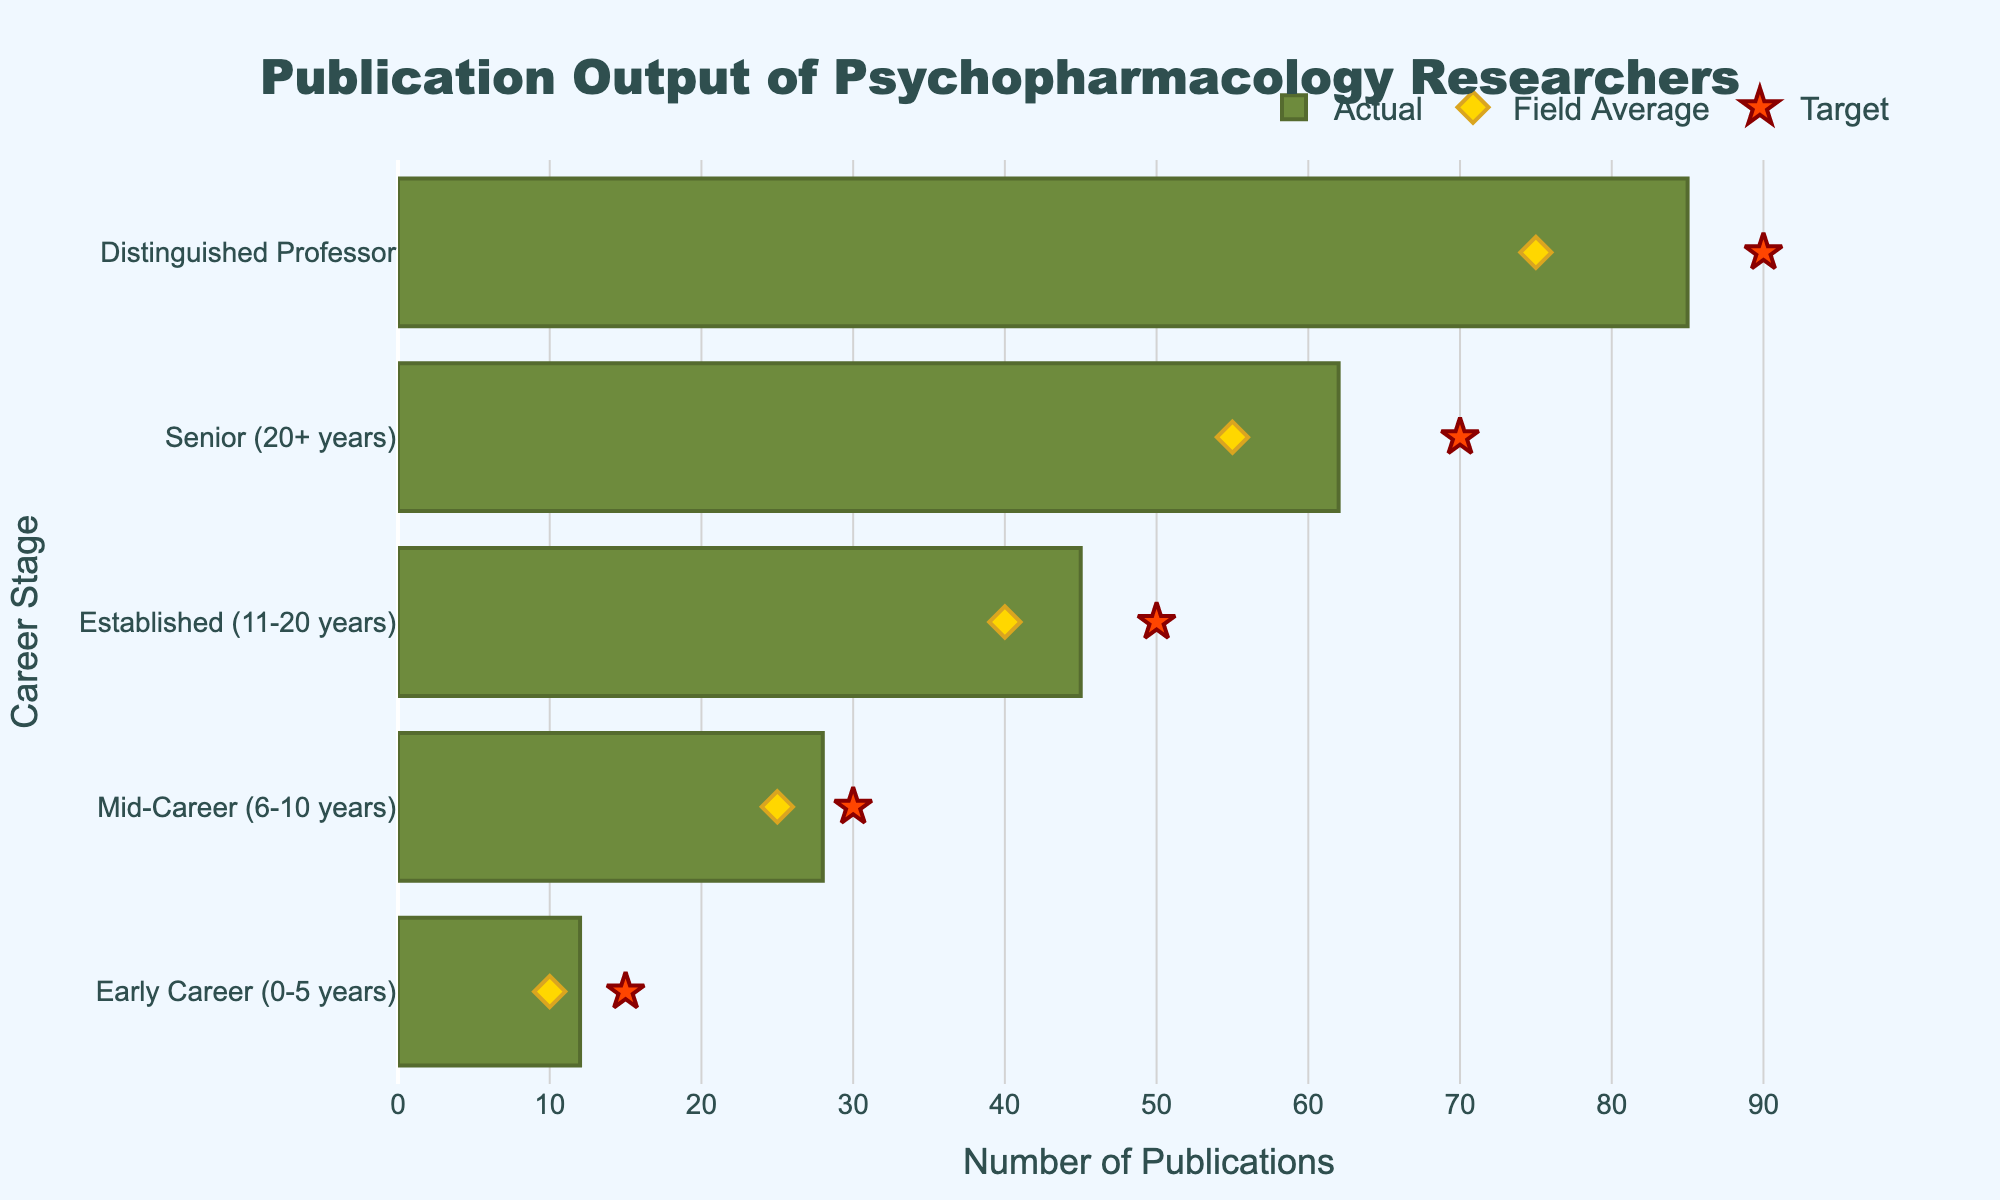How many career stages are illustrated in the chart? There are different career stages listed on the y-axis of the chart. Counting them will give us the total number of career stages.
Answer: Five What is the title of the chart? The title is displayed prominently at the top center of the chart.
Answer: Publication Output of Psychopharmacology Researchers What is the actual publication output for Mid-Career researchers? Look for the Mid-Career category on the y-axis and identify the length of the corresponding bar.
Answer: 28 What is the difference between the actual publication output and the target for Early Career researchers? For Early Career researchers, subtract the actual value (12) from the target value (15).
Answer: 3 Which career stage has the highest Field Average publication output? Compare the Field Average markers (yellow diamonds) for all career stages and identify the highest one.
Answer: Distinguished Professor What is the average Target publication output across all career stages? Sum the Target values for all career stages (15 + 30 + 50 + 70 + 90) and divide by the number of career stages (5).
Answer: 51 How many more publications do Senior researchers have compared to the Field Average for the same stage? Subtract the Field Average for Senior researchers (55) from their Actual publication output (62).
Answer: 7 Which career stage has the largest gap between Actual and Comparative publication outputs? Calculate the gap for each category by subtracting Comparative from Actual and identify the largest one.
Answer: Distinguished Professor What color are the bars representing actual publication output? Look at the color of the bars representing the actual publication output.
Answer: Green By how much does the Distinguished Professor's actual publication output exceed the Mid-Career researchers' target? Subtract the target value of Mid-Career researchers (30) from the actual value of Distinguished Professors (85).
Answer: 55 